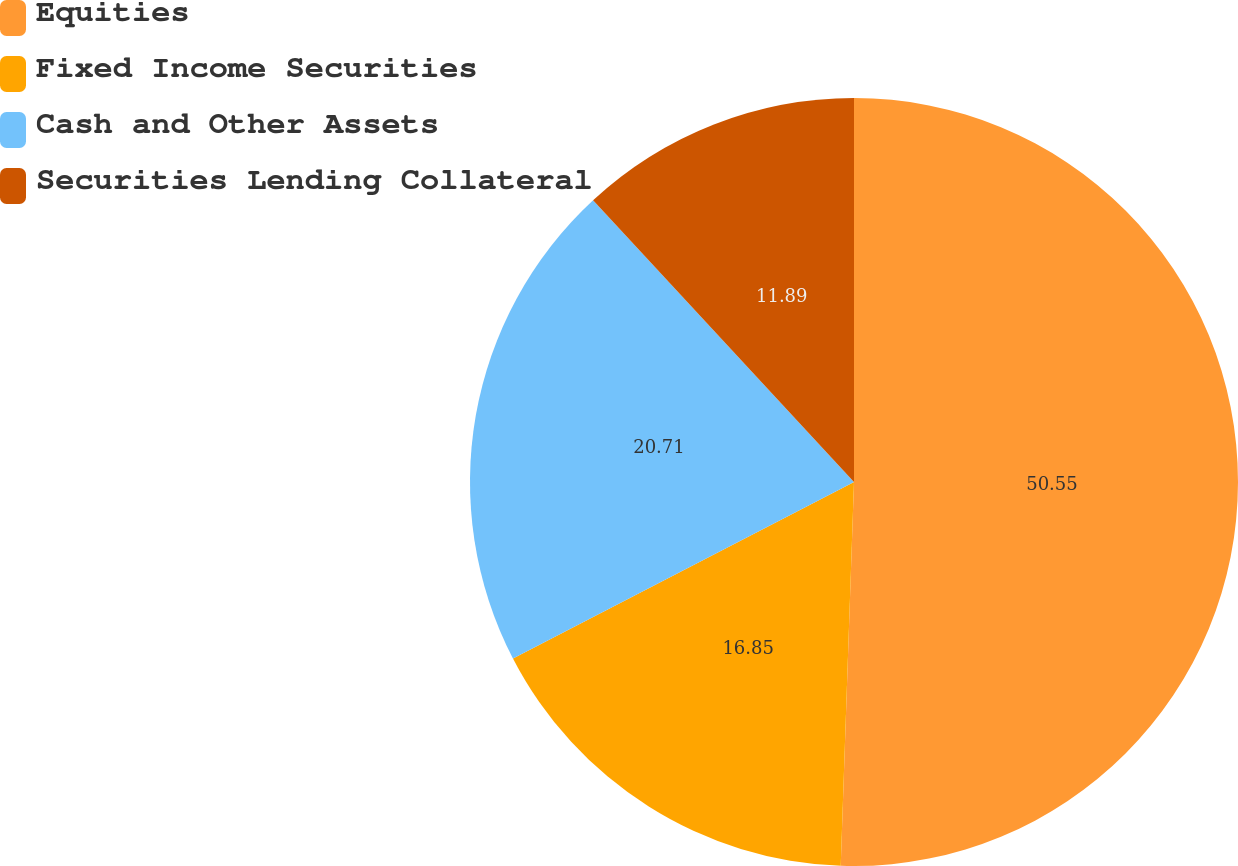Convert chart to OTSL. <chart><loc_0><loc_0><loc_500><loc_500><pie_chart><fcel>Equities<fcel>Fixed Income Securities<fcel>Cash and Other Assets<fcel>Securities Lending Collateral<nl><fcel>50.55%<fcel>16.85%<fcel>20.71%<fcel>11.89%<nl></chart> 